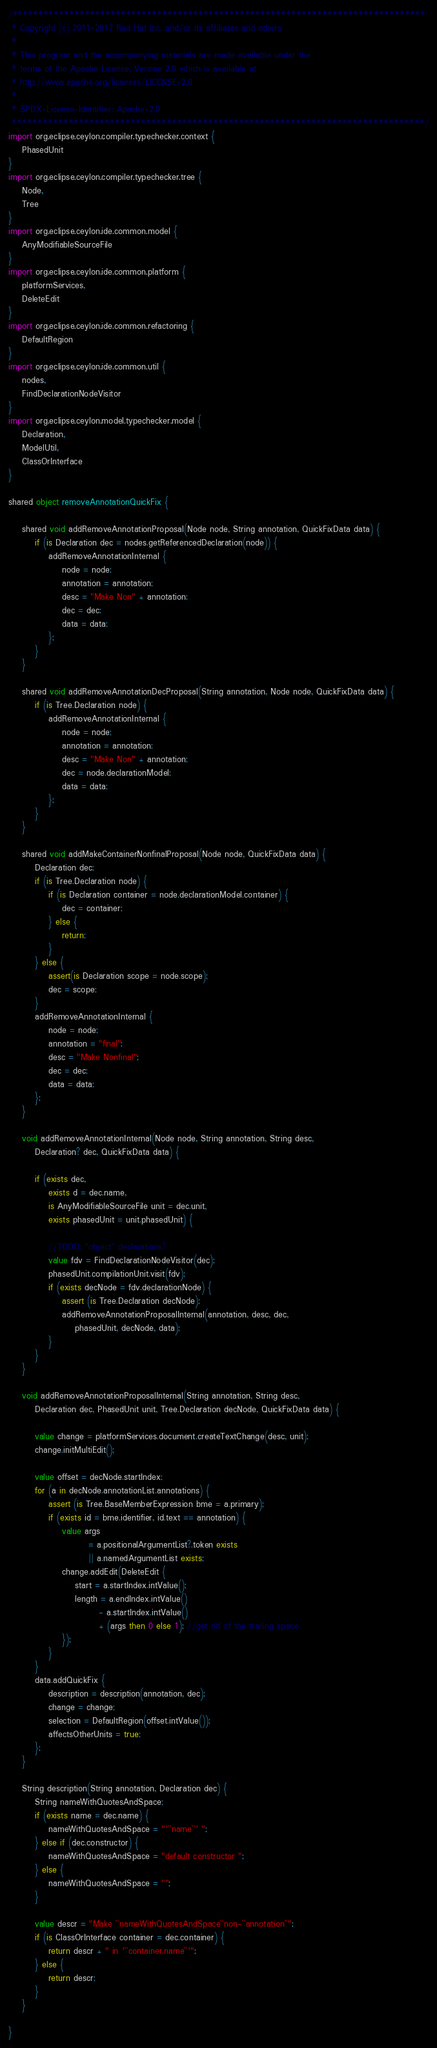<code> <loc_0><loc_0><loc_500><loc_500><_Ceylon_>/********************************************************************************
 * Copyright (c) 2011-2017 Red Hat Inc. and/or its affiliates and others
 *
 * This program and the accompanying materials are made available under the 
 * terms of the Apache License, Version 2.0 which is available at
 * http://www.apache.org/licenses/LICENSE-2.0
 *
 * SPDX-License-Identifier: Apache-2.0 
 ********************************************************************************/
import org.eclipse.ceylon.compiler.typechecker.context {
    PhasedUnit
}
import org.eclipse.ceylon.compiler.typechecker.tree {
    Node,
    Tree
}
import org.eclipse.ceylon.ide.common.model {
    AnyModifiableSourceFile
}
import org.eclipse.ceylon.ide.common.platform {
    platformServices,
    DeleteEdit
}
import org.eclipse.ceylon.ide.common.refactoring {
    DefaultRegion
}
import org.eclipse.ceylon.ide.common.util {
    nodes,
    FindDeclarationNodeVisitor
}
import org.eclipse.ceylon.model.typechecker.model {
    Declaration,
    ModelUtil,
    ClassOrInterface
}

shared object removeAnnotationQuickFix {
    
    shared void addRemoveAnnotationProposal(Node node, String annotation, QuickFixData data) {
        if (is Declaration dec = nodes.getReferencedDeclaration(node)) {
            addRemoveAnnotationInternal {
                node = node;
                annotation = annotation;
                desc = "Make Non" + annotation;
                dec = dec;
                data = data;
            };
        }
    }

    shared void addRemoveAnnotationDecProposal(String annotation, Node node, QuickFixData data) {
        if (is Tree.Declaration node) {
            addRemoveAnnotationInternal {
                node = node;
                annotation = annotation;
                desc = "Make Non" + annotation;
                dec = node.declarationModel;
                data = data;
            };
        }
    }

    shared void addMakeContainerNonfinalProposal(Node node, QuickFixData data) {
        Declaration dec;
        if (is Tree.Declaration node) {
            if (is Declaration container = node.declarationModel.container) {
                dec = container;
            } else {
                return;
            }
        } else {
            assert(is Declaration scope = node.scope);
            dec = scope;
        }
        addRemoveAnnotationInternal {
            node = node;
            annotation = "final";
            desc = "Make Nonfinal";
            dec = dec;
            data = data;
        };
    }
    
    void addRemoveAnnotationInternal(Node node, String annotation, String desc,
        Declaration? dec, QuickFixData data) {
        
        if (exists dec,
            exists d = dec.name,
            is AnyModifiableSourceFile unit = dec.unit,
            exists phasedUnit = unit.phasedUnit) {

            //TODO: "object" declarations?
            value fdv = FindDeclarationNodeVisitor(dec);
            phasedUnit.compilationUnit.visit(fdv);
            if (exists decNode = fdv.declarationNode) {
                assert (is Tree.Declaration decNode);
                addRemoveAnnotationProposalInternal(annotation, desc, dec,
                    phasedUnit, decNode, data);
            }
        }
    }
    
    void addRemoveAnnotationProposalInternal(String annotation, String desc,
        Declaration dec, PhasedUnit unit, Tree.Declaration decNode, QuickFixData data) {

        value change = platformServices.document.createTextChange(desc, unit);
        change.initMultiEdit();

        value offset = decNode.startIndex;
        for (a in decNode.annotationList.annotations) {
            assert (is Tree.BaseMemberExpression bme = a.primary);
            if (exists id = bme.identifier, id.text == annotation) {
                value args
                        = a.positionalArgumentList?.token exists
                        || a.namedArgumentList exists;
                change.addEdit(DeleteEdit {
                    start = a.startIndex.intValue();
                    length = a.endIndex.intValue()
                           - a.startIndex.intValue()
                           + (args then 0 else 1); //get rid of the trailing space
                });
            }
        }
        data.addQuickFix {
            description = description(annotation, dec);
            change = change;
            selection = DefaultRegion(offset.intValue());
            affectsOtherUnits = true;
        };
    }
    
    String description(String annotation, Declaration dec) {
        String nameWithQuotesAndSpace;
        if (exists name = dec.name) {
            nameWithQuotesAndSpace = "'``name``' ";
        } else if (dec.constructor) {
            nameWithQuotesAndSpace = "default constructor ";
        } else {
            nameWithQuotesAndSpace = "";
        }

        value descr = "Make ``nameWithQuotesAndSpace``non-``annotation``";
        if (is ClassOrInterface container = dec.container) {
            return descr + " in '``container.name``'";
        } else {
            return descr;
        }
    }

}
</code> 